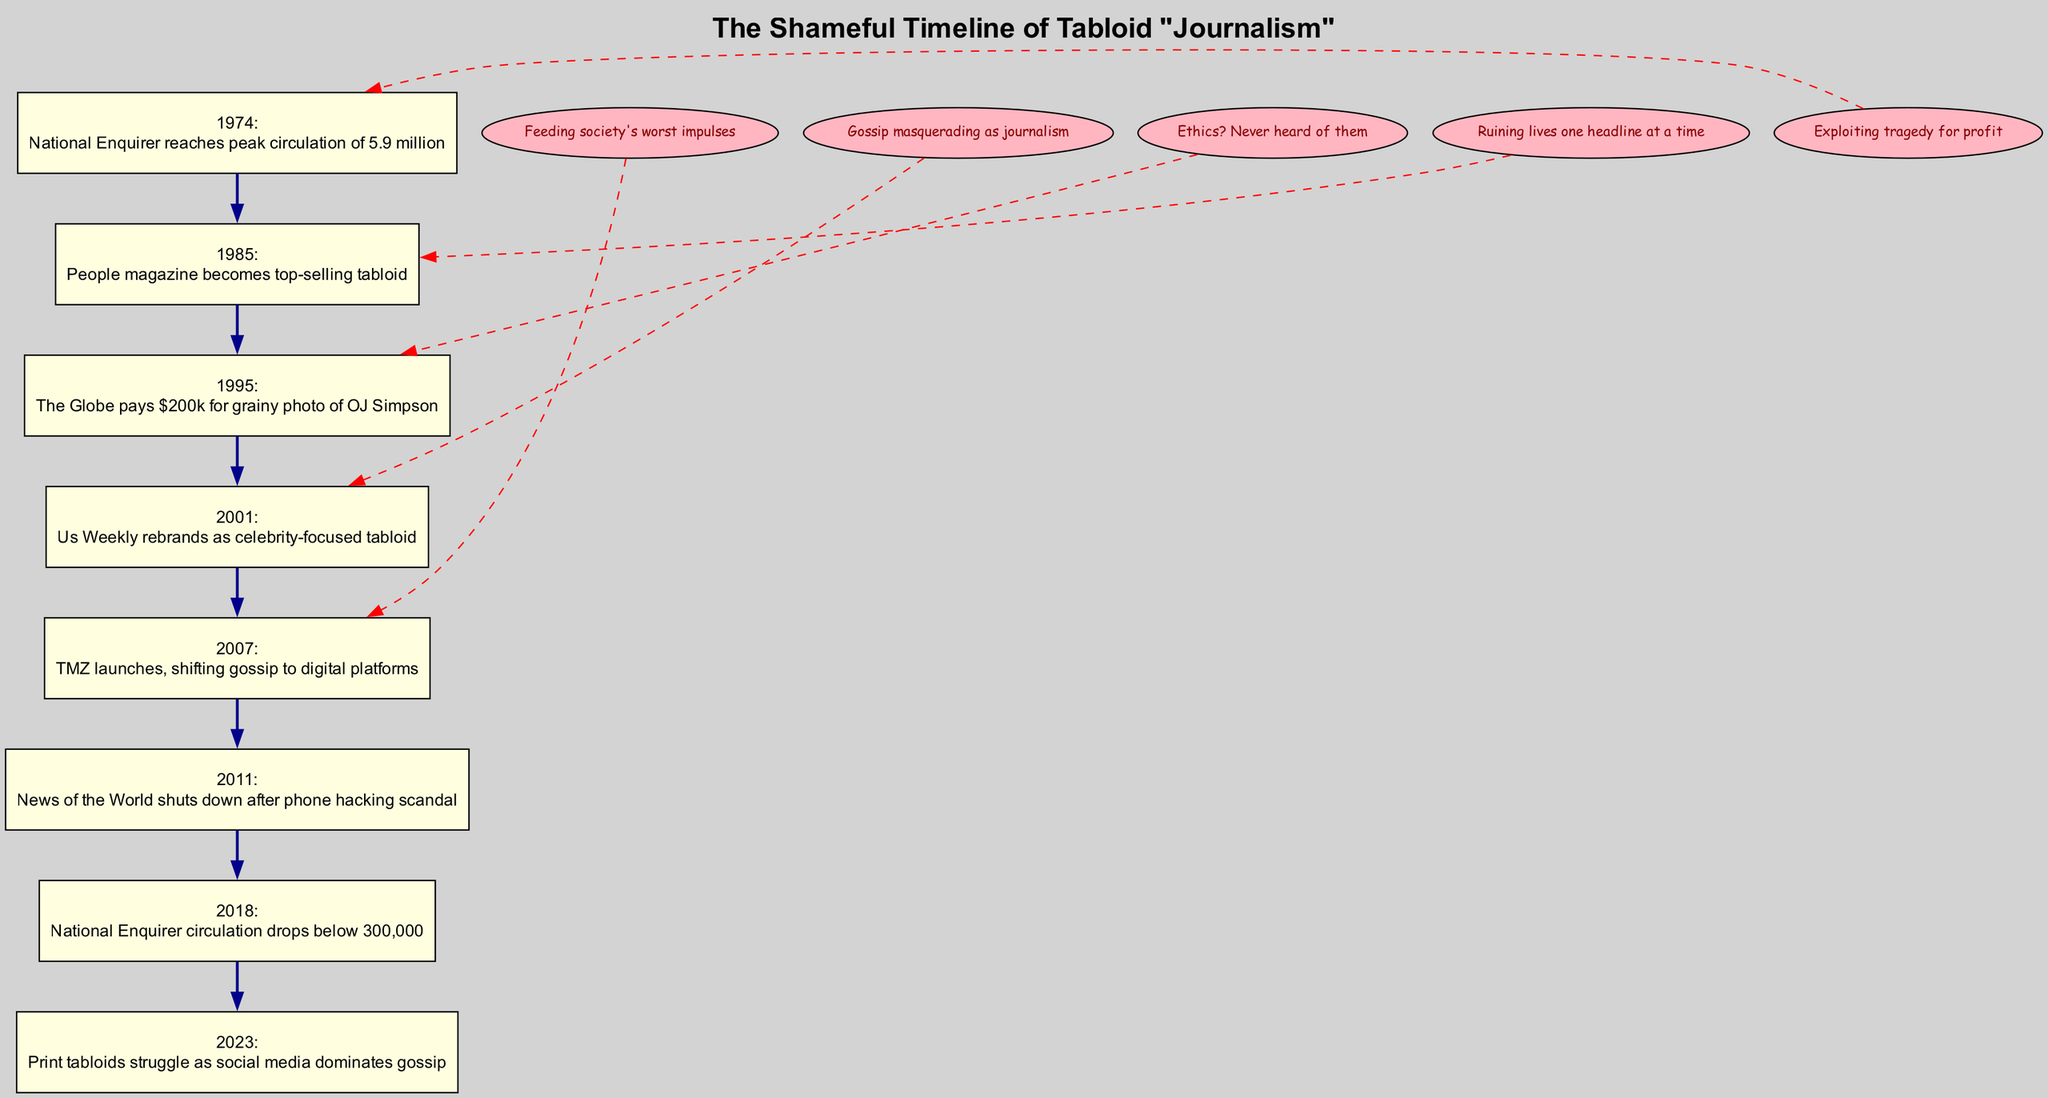What year did the National Enquirer reach peak circulation? The diagram shows that the National Enquirer reached its peak circulation in 1974 according to the node labeled with that year.
Answer: 1974 What was the peak circulation of the National Enquirer? Referring to the event detailed in the 1974 node, it states that the peak circulation was 5.9 million copies.
Answer: 5.9 million Which publication became the top-selling tabloid in 1985? The node for the year 1985 specifies that People magazine became the top-selling tabloid that year.
Answer: People magazine How many significant events are shown in the timeline? Counting the nodes in the timeline from 1974 to 2023, there are a total of eight significant events listed.
Answer: 8 In what year did Us Weekly rebrand? The node for the year 2001 indicates that Us Weekly rebranded as a celebrity-focused tabloid.
Answer: 2001 What comment is linked to the National Enquirer’s drop in circulation? The diagram connects the comment "Exploiting tragedy for profit" to the node for the year 2018 when the National Enquirer’s circulation dropped below 300,000.
Answer: Exploiting tragedy for profit What pivotal event happened in 2011? Referring to the timeline, the year 2011 is marked with the shutdown of News of the World after a phone hacking scandal.
Answer: News of the World shuts down after phone hacking scandal How does the rise of digital platforms relate to tabloids? The node from 2007 mentions that the launch of TMZ shifted gossip to digital platforms, indicating a significant transformation in the way gossip was disseminated.
Answer: TMZ launches What trend does the diagram illustrate from 1974 to 2023 about print tabloids? Review of the timeline shows a notable decline in print tabloids exemplified by the event in 2018 where National Enquirer’s circulation drops significantly, and the 2023 note mentions struggles against social media.
Answer: Print tabloids struggle as social media dominates gossip 